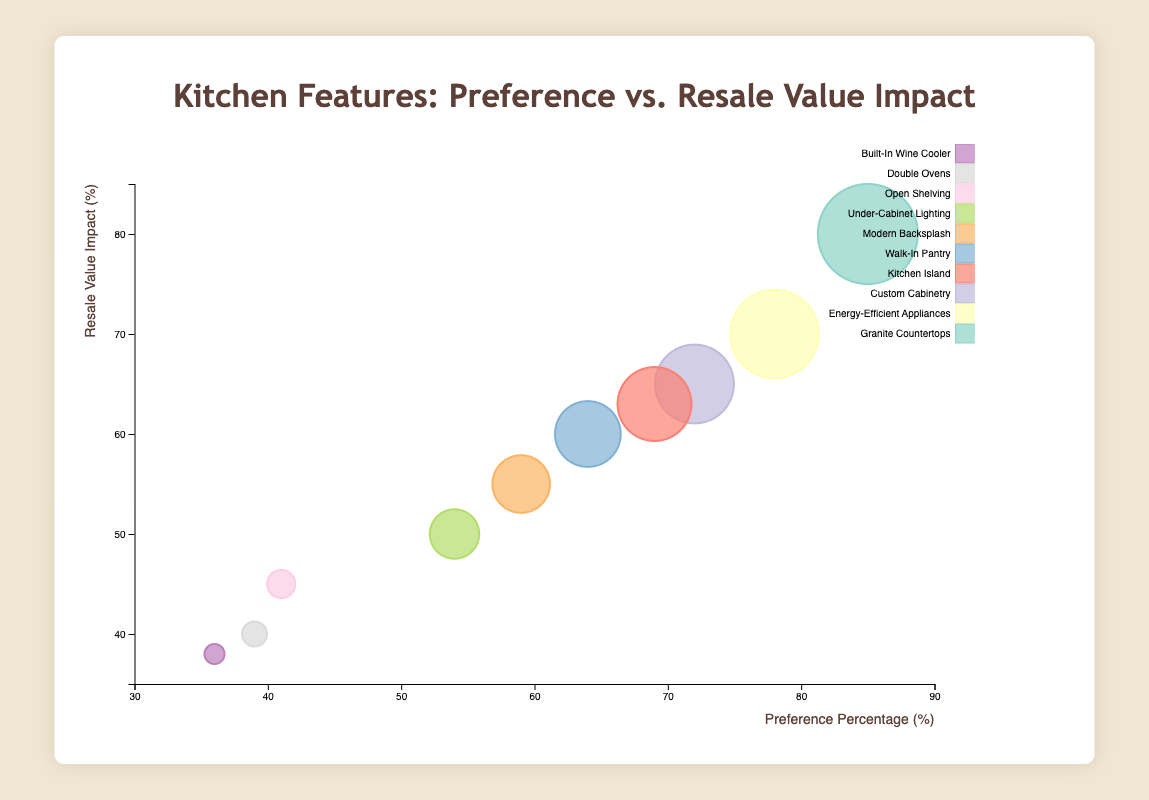Which kitchen feature has the highest preference percentage? The highest preference percentage can be identified by looking at the bubble that is farthest to the right on the x-axis. The Granite Countertops bubble is at 85%, which is the highest.
Answer: Granite Countertops Which feature has the lowest resale value impact? The lowest resale value impact can be identified by looking at the bubble closest to the bottom on the y-axis. The Built-In Wine Cooler feature has a resale value impact of 38%, which is the lowest.
Answer: Built-In Wine Cooler What is the preference percentage of Double Ovens? Locate the Double Ovens bubble and observe its position on the x-axis. The preference percentage for Double Ovens is 39%.
Answer: 39% Which features have a resale value impact of over 60%? Identify bubbles that are above the 60% mark on the y-axis. The features are Granite Countertops, Energy-Efficient Appliances, Custom Cabinetry, Kitchen Island, and Walk-In Pantry.
Answer: Granite Countertops, Energy-Efficient Appliances, Custom Cabinetry, Kitchen Island, Walk-In Pantry What feature has both a high preference percentage and a high resale value impact? Look for features that have values high on both the x and y axes. Granite Countertops appears both near the upper end of preference percentages and resale value impact, with 85% and 80%, respectively.
Answer: Granite Countertops How many features have a resale value impact between 55% and 70%? Count the bubbles that lie on the y-axis between 55% and 70%. The features are Energy-Efficient Appliances, Custom Cabinetry, Modern Backsplash, Kitchen Island, and Walk-In Pantry, totaling to five.
Answer: 5 Compare the preference percentage between Open Shelving and Under-Cabinet Lighting. Which one is higher? Locate both features on the x-axis and compare their positions. Open Shelving has a preference percentage of 41%, while Under-Cabinet Lighting has 54%, which is higher.
Answer: Under-Cabinet Lighting What's the total preference percentage for all listed kitchen features? Add up the preference percentages of all the features: 85 + 78 + 72 + 69 + 64 + 59 + 54 + 41 + 39 + 36 = 597.
Answer: 597 What is the average resale value impact of the features? Sum all resale value impacts: 80 + 70 + 65 + 63 + 60 + 55 + 50 + 45 + 40 + 38 = 566. Then divide by the number of features (10): 566 / 10 = 56.6.
Answer: 56.6 What percentage difference is there between the resale value impact of Energy-Efficient Appliances and Modern Backsplash? Subtract the resale value impact of Modern Backsplash from Energy-Efficient Appliances: 70% - 55% = 15%.
Answer: 15% 